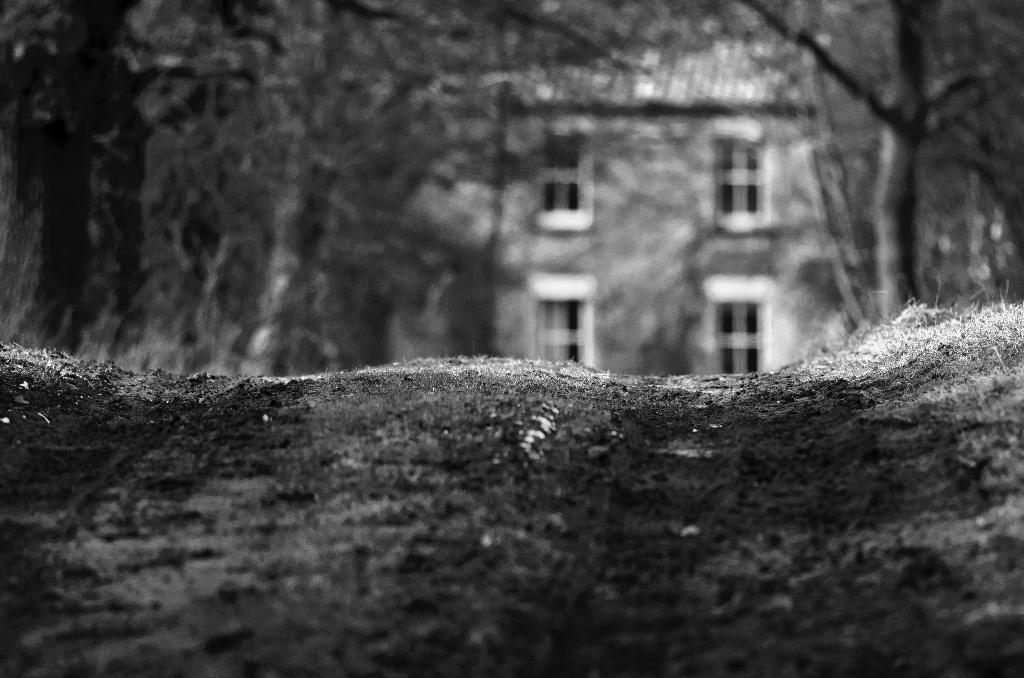What is located at the bottom of the image? There is a road at the bottom of the image. What can be seen in the background of the image? There are trees and a building in the background of the image. What is the color scheme of the image? The image is in black and white. How is the background of the image depicted? The background of the image is blurred. What type of jam is being advertised on the road in the image? There is no jam or advertisement present in the image; it features a road, trees, a building, and a blurred background. How does the road shake in the image? The road does not shake in the image; it is a still, stationary image. 